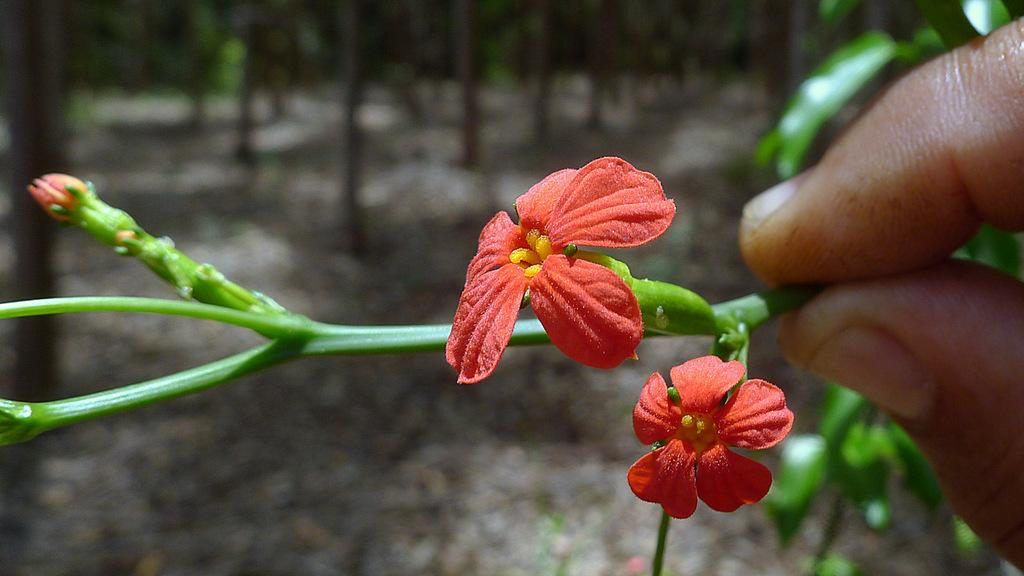What is the human hand holding in the image? There is a human hand holding a plant in the image. What type of plant is being held? The plant has flowers, as mentioned in the facts. What can be seen in the background of the image? There are trees in the background of the image. How is the background of the image depicted? The background of the image is blurred. What time is displayed on the clock in the image? There is no clock present in the image, so it is not possible to determine the time. 